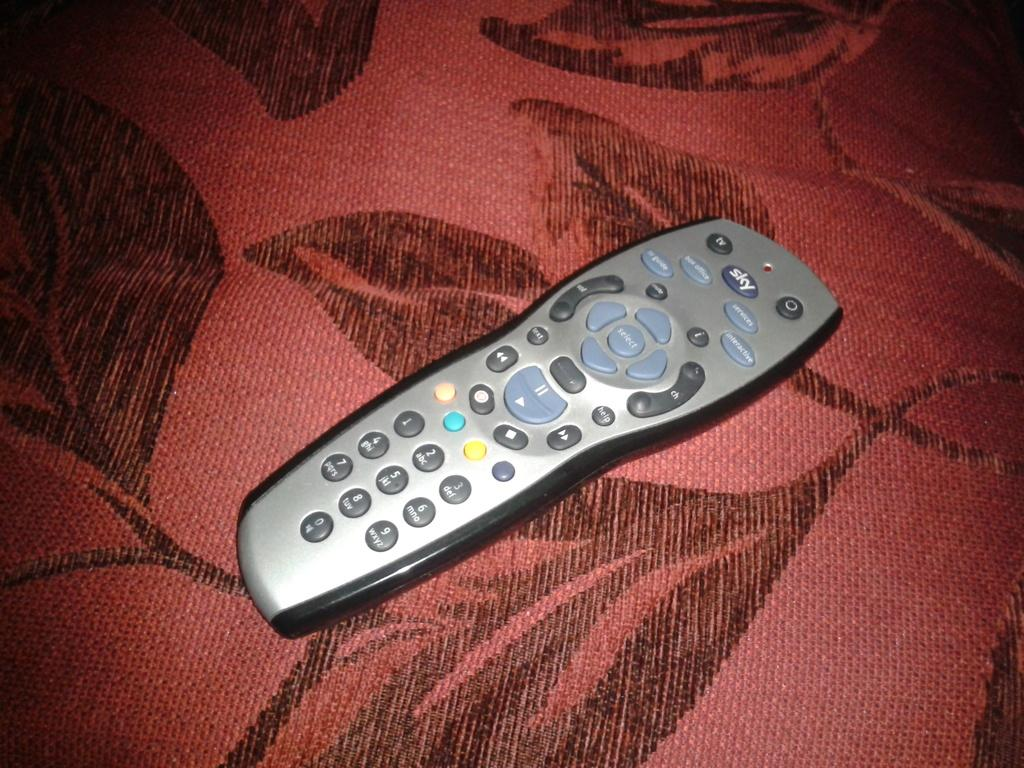Provide a one-sentence caption for the provided image. Remote controller with a large SKY button near the top. 